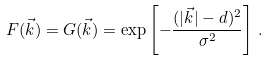<formula> <loc_0><loc_0><loc_500><loc_500>F ( \vec { k } ) = G ( \vec { k } ) = \exp \left [ - \frac { ( | \vec { k } | - d ) ^ { 2 } } { \sigma ^ { 2 } } \right ] \, .</formula> 